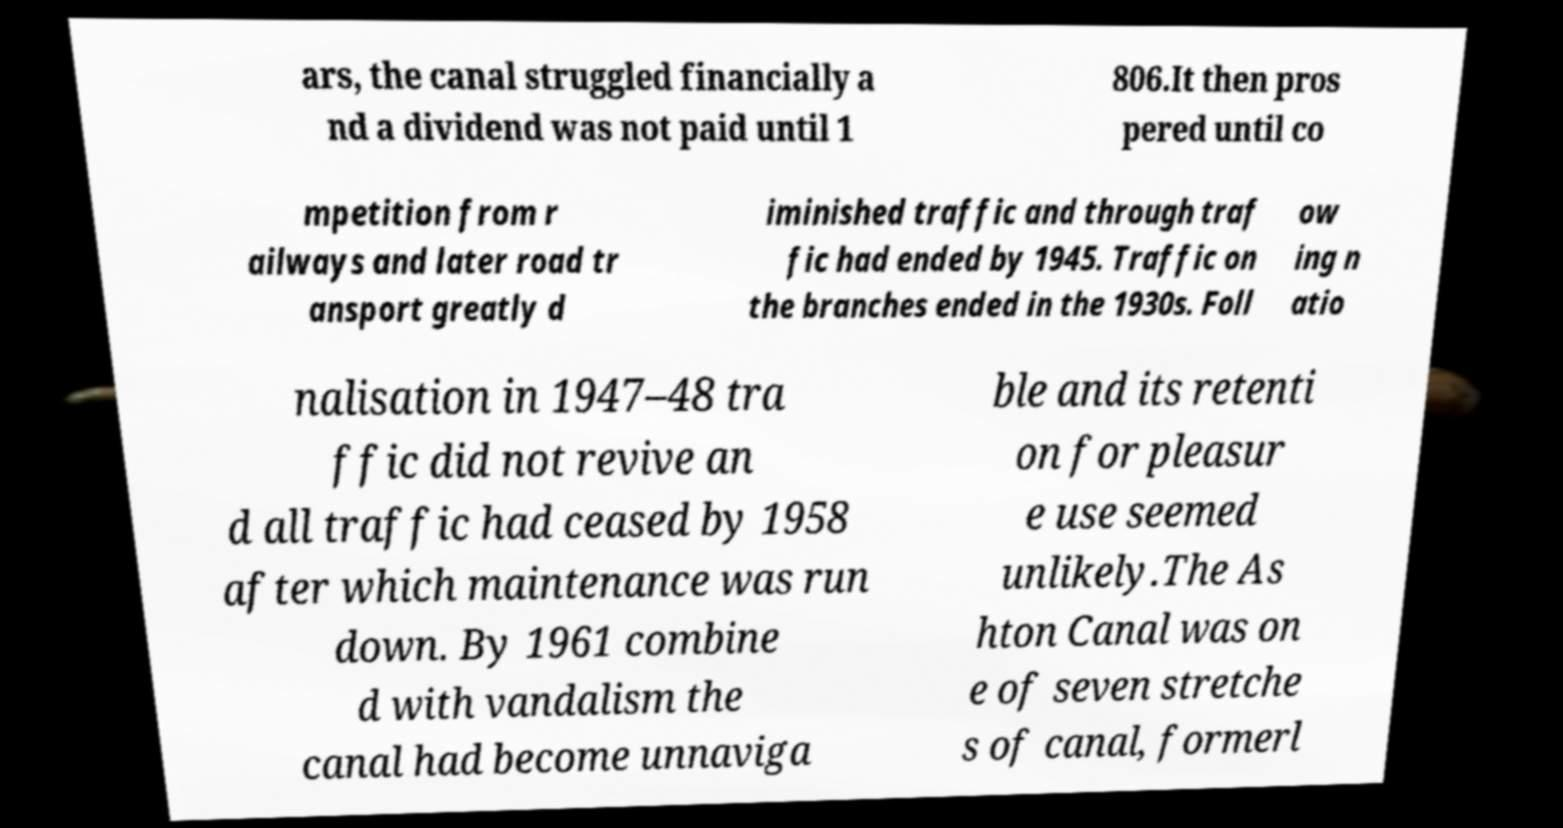Can you accurately transcribe the text from the provided image for me? ars, the canal struggled financially a nd a dividend was not paid until 1 806.It then pros pered until co mpetition from r ailways and later road tr ansport greatly d iminished traffic and through traf fic had ended by 1945. Traffic on the branches ended in the 1930s. Foll ow ing n atio nalisation in 1947–48 tra ffic did not revive an d all traffic had ceased by 1958 after which maintenance was run down. By 1961 combine d with vandalism the canal had become unnaviga ble and its retenti on for pleasur e use seemed unlikely.The As hton Canal was on e of seven stretche s of canal, formerl 